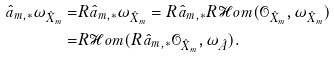Convert formula to latex. <formula><loc_0><loc_0><loc_500><loc_500>\hat { a } _ { m , * } \omega _ { \hat { X } _ { m } } = & R \hat { a } _ { m , * } \omega _ { \hat { X } _ { m } } = R \hat { a } _ { m , * } R \mathcal { H } o m ( \mathcal { O } _ { \hat { X } _ { m } } , \omega _ { \hat { X } _ { m } } ) \\ = & R \mathcal { H } o m ( R \hat { a } _ { m , * } \mathcal { O } _ { \hat { X } _ { m } } , \omega _ { \hat { A } } ) .</formula> 